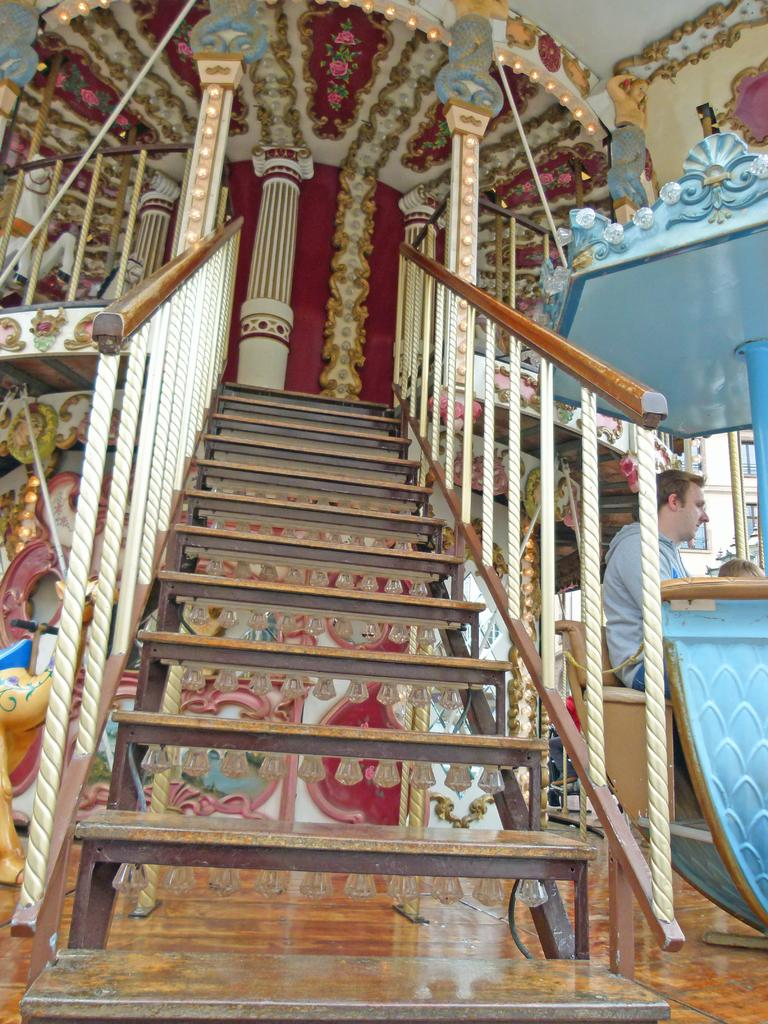What type of structure is present in the image? There are stairs in the image. What is the man in the image doing? The man is seated in the image. What type of decorations can be seen on the wall in the image? There are carvings on the wall in the image. What type of decorations can be seen on the roof in the image? There are carvings on the roof in the image. What type of sheet is covering the man in the image? There is no sheet covering the man in the image; he is seated without any covering. What type of screw can be seen holding the carvings on the wall in the image? There are no screws visible in the image; the carvings are attached to the wall in a different manner. 